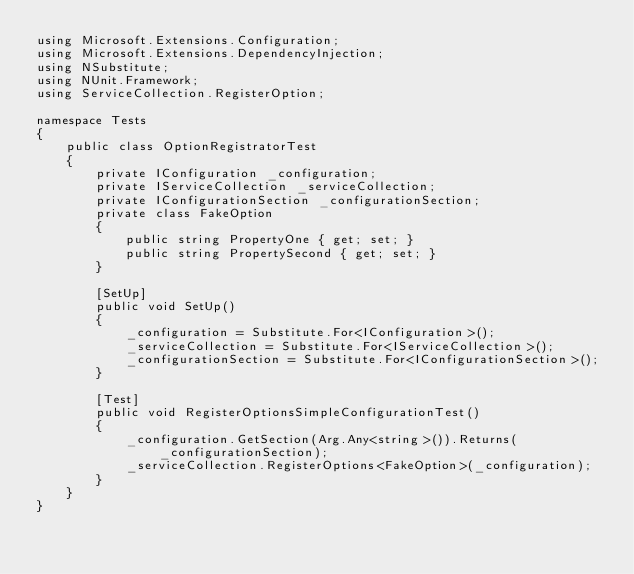Convert code to text. <code><loc_0><loc_0><loc_500><loc_500><_C#_>using Microsoft.Extensions.Configuration;
using Microsoft.Extensions.DependencyInjection;
using NSubstitute;
using NUnit.Framework;
using ServiceCollection.RegisterOption;

namespace Tests
{
    public class OptionRegistratorTest
    {
        private IConfiguration _configuration;
        private IServiceCollection _serviceCollection;
        private IConfigurationSection _configurationSection;
        private class FakeOption
        {
            public string PropertyOne { get; set; }
            public string PropertySecond { get; set; }
        }
        
        [SetUp]
        public void SetUp()
        {
            _configuration = Substitute.For<IConfiguration>();
            _serviceCollection = Substitute.For<IServiceCollection>();
            _configurationSection = Substitute.For<IConfigurationSection>();
        }

        [Test]
        public void RegisterOptionsSimpleConfigurationTest()
        {
            _configuration.GetSection(Arg.Any<string>()).Returns(_configurationSection);
            _serviceCollection.RegisterOptions<FakeOption>(_configuration);
        }
    }
}</code> 